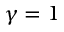Convert formula to latex. <formula><loc_0><loc_0><loc_500><loc_500>\gamma = 1</formula> 